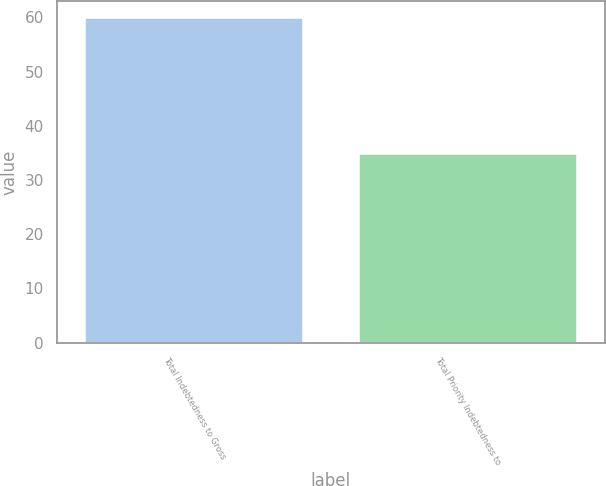Convert chart to OTSL. <chart><loc_0><loc_0><loc_500><loc_500><bar_chart><fcel>Total Indebtedness to Gross<fcel>Total Priority Indebtedness to<nl><fcel>60<fcel>35<nl></chart> 